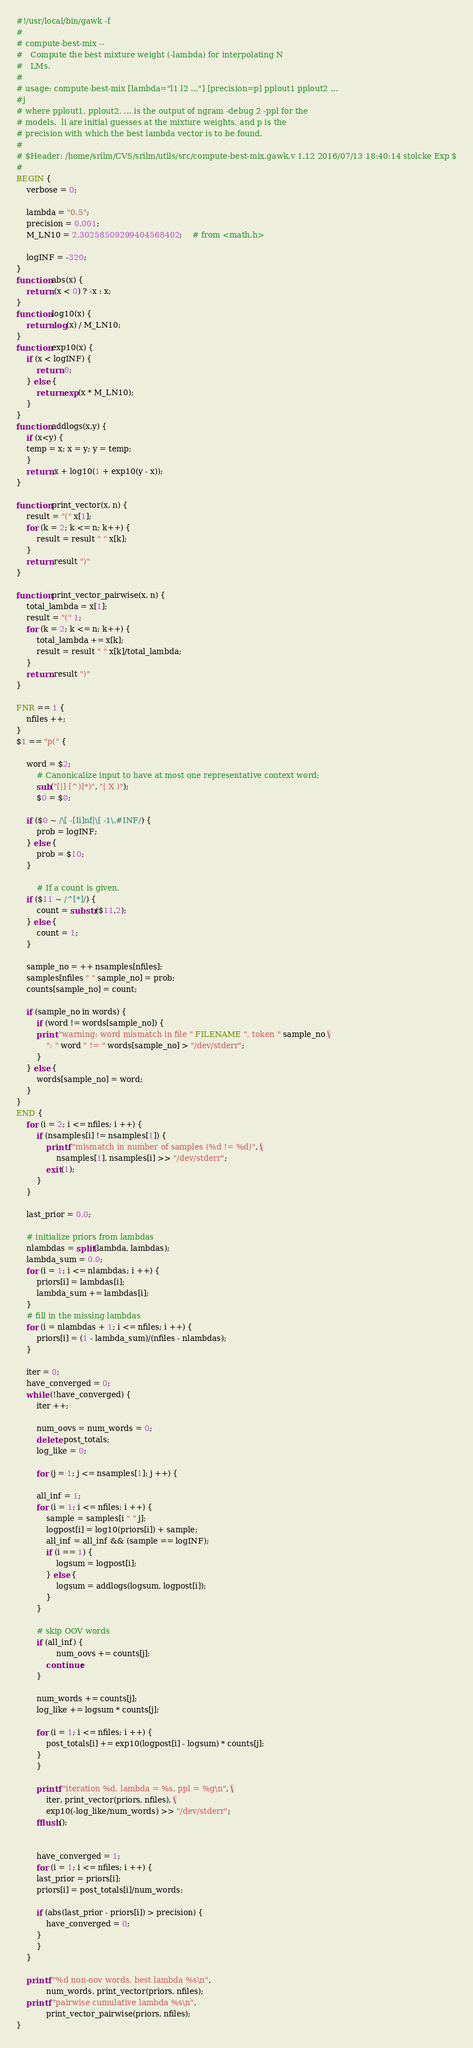<code> <loc_0><loc_0><loc_500><loc_500><_Awk_>#!/usr/local/bin/gawk -f
#
# compute-best-mix --
#	Compute the best mixture weight (-lambda) for interpolating N
#	LMs.
#
# usage: compute-best-mix [lambda="l1 l2 ..."] [precision=p] pplout1 pplout2 ...
#j
# where pplout1, pplout2, ... is the output of ngram -debug 2 -ppl for the 
# models.  li are initial guesses at the mixture weights, and p is the
# precision with which the best lambda vector is to be found.
#
# $Header: /home/srilm/CVS/srilm/utils/src/compute-best-mix.gawk,v 1.12 2016/07/13 18:40:14 stolcke Exp $
#
BEGIN {
	verbose = 0;

	lambda = "0.5";
	precision = 0.001;
	M_LN10 = 2.30258509299404568402;	# from <math.h>

	logINF = -320;
}
function abs(x) {
	return (x < 0) ? -x : x;
}
function log10(x) {
	return log(x) / M_LN10;
}
function exp10(x) {
	if (x < logINF) {
		return 0;
	} else {
		return exp(x * M_LN10);
	}
}
function addlogs(x,y) {
    if (x<y) {
	temp = x; x = y; y = temp;
    }
    return x + log10(1 + exp10(y - x));
}

function print_vector(x, n) {
	result = "(" x[1];
	for (k = 2; k <= n; k++) {
		result = result " " x[k];
	}
	return result ")"
}

function print_vector_pairwise(x, n) {
	total_lambda = x[1];
	result = "(" 1;
	for (k = 2; k <= n; k++) {
		total_lambda += x[k];
		result = result " " x[k]/total_lambda;
	}
	return result ")"
}

FNR == 1 {
	nfiles ++;
}
$1 == "p(" {

	word = $2;
        # Canonicalize input to have at most one representative context word; 
        sub("[|] [^)]*)", "| X )");
        $0 = $0;

	if ($0 ~ /\[ -[Ii]nf|\[ -1\.#INF/) {
	    prob = logINF;
	} else {
	    prob = $10;
	}

        # If a count is given.
	if ($11 ~ /^[*]/) {
	    count = substr($11,2);
	} else {
	    count = 1;
	}

	sample_no = ++ nsamples[nfiles];
	samples[nfiles " " sample_no] = prob;
	counts[sample_no] = count;

	if (sample_no in words) {
	    if (word != words[sample_no]) {
		print "warning: word mismatch in file " FILENAME ", token " sample_no \
			": " word " != " words[sample_no] > "/dev/stderr";
	    }
	} else {
	    words[sample_no] = word;
	}
}
END {
	for (i = 2; i <= nfiles; i ++) {
		if (nsamples[i] != nsamples[1]) {
			printf "mismatch in number of samples (%d != %d)", \
				nsamples[1], nsamples[i] >> "/dev/stderr";
			exit(1);
		}
	}

	last_prior = 0.0;

	# initialize priors from lambdas
	nlambdas = split(lambda, lambdas);
	lambda_sum = 0.0;
	for (i = 1; i <= nlambdas; i ++) {
		priors[i] = lambdas[i];
		lambda_sum += lambdas[i];
	}
	# fill in the missing lambdas
	for (i = nlambdas + 1; i <= nfiles; i ++) {
		priors[i] = (1 - lambda_sum)/(nfiles - nlambdas);
	}

	iter = 0;
	have_converged = 0;
	while (!have_converged) {
	    iter ++;

	    num_oovs = num_words = 0;
	    delete post_totals;
	    log_like = 0;

	    for (j = 1; j <= nsamples[1]; j ++) {

		all_inf = 1;
		for (i = 1; i <= nfiles; i ++) {
			sample = samples[i " " j];
			logpost[i] = log10(priors[i]) + sample;
			all_inf = all_inf && (sample == logINF);
			if (i == 1) {
				logsum = logpost[i];
			} else {
				logsum = addlogs(logsum, logpost[i]);
			}
		}

		# skip OOV words
		if (all_inf) {
   		        num_oovs += counts[j];
			continue;
		}

		num_words += counts[j];
		log_like += logsum * counts[j];

		for (i = 1; i <= nfiles; i ++) {
			post_totals[i] += exp10(logpost[i] - logsum) * counts[j];
		}
	    }

	    printf "iteration %d, lambda = %s, ppl = %g\n", \
		    iter, print_vector(priors, nfiles), \
		    exp10(-log_like/num_words) >> "/dev/stderr";
	    fflush();

	
	    have_converged = 1;
	    for (i = 1; i <= nfiles; i ++) {
		last_prior = priors[i];
		priors[i] = post_totals[i]/num_words;

		if (abs(last_prior - priors[i]) > precision) {
			have_converged = 0;
		}
	    }
	}

	printf "%d non-oov words, best lambda %s\n", 
			num_words, print_vector(priors, nfiles);
	printf "pairwise cumulative lambda %s\n", 
			print_vector_pairwise(priors, nfiles);
}
</code> 